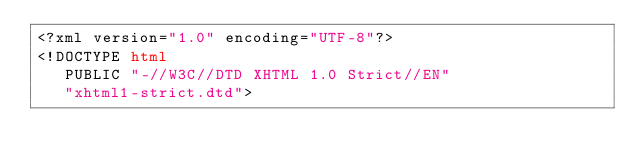<code> <loc_0><loc_0><loc_500><loc_500><_HTML_><?xml version="1.0" encoding="UTF-8"?>
<!DOCTYPE html
   PUBLIC "-//W3C//DTD XHTML 1.0 Strict//EN"
   "xhtml1-strict.dtd"></code> 